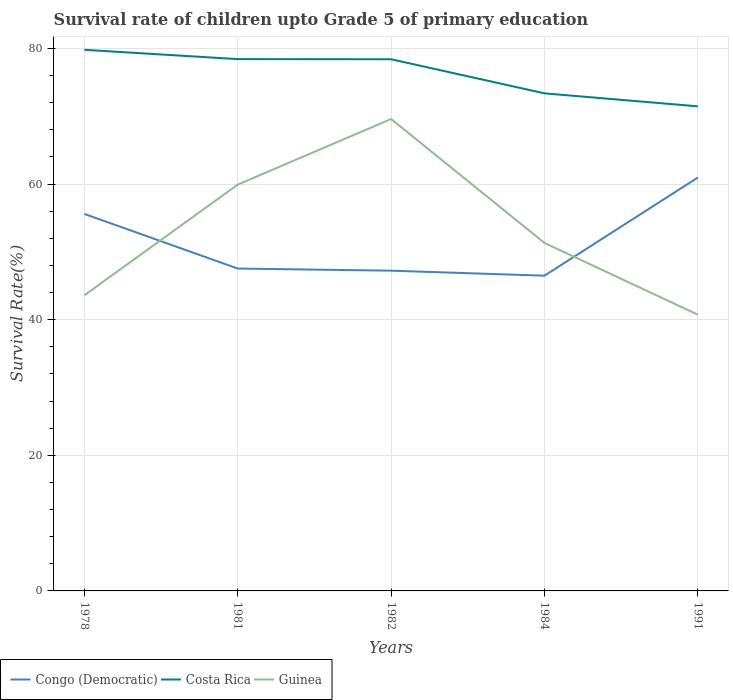Does the line corresponding to Guinea intersect with the line corresponding to Congo (Democratic)?
Offer a very short reply. Yes. Is the number of lines equal to the number of legend labels?
Keep it short and to the point. Yes. Across all years, what is the maximum survival rate of children in Guinea?
Ensure brevity in your answer.  40.74. What is the total survival rate of children in Guinea in the graph?
Provide a short and direct response. 8.6. What is the difference between the highest and the second highest survival rate of children in Costa Rica?
Ensure brevity in your answer.  8.34. Is the survival rate of children in Costa Rica strictly greater than the survival rate of children in Guinea over the years?
Make the answer very short. No. How many lines are there?
Provide a succinct answer. 3. How many years are there in the graph?
Your answer should be very brief. 5. What is the difference between two consecutive major ticks on the Y-axis?
Your answer should be compact. 20. Does the graph contain grids?
Provide a succinct answer. Yes. Where does the legend appear in the graph?
Provide a short and direct response. Bottom left. What is the title of the graph?
Your response must be concise. Survival rate of children upto Grade 5 of primary education. Does "Italy" appear as one of the legend labels in the graph?
Offer a terse response. No. What is the label or title of the X-axis?
Your answer should be compact. Years. What is the label or title of the Y-axis?
Offer a very short reply. Survival Rate(%). What is the Survival Rate(%) in Congo (Democratic) in 1978?
Provide a succinct answer. 55.59. What is the Survival Rate(%) in Costa Rica in 1978?
Your answer should be very brief. 79.79. What is the Survival Rate(%) in Guinea in 1978?
Offer a terse response. 43.6. What is the Survival Rate(%) of Congo (Democratic) in 1981?
Your answer should be compact. 47.54. What is the Survival Rate(%) of Costa Rica in 1981?
Make the answer very short. 78.42. What is the Survival Rate(%) in Guinea in 1981?
Make the answer very short. 59.92. What is the Survival Rate(%) in Congo (Democratic) in 1982?
Keep it short and to the point. 47.23. What is the Survival Rate(%) in Costa Rica in 1982?
Ensure brevity in your answer.  78.4. What is the Survival Rate(%) in Guinea in 1982?
Your response must be concise. 69.59. What is the Survival Rate(%) of Congo (Democratic) in 1984?
Offer a very short reply. 46.48. What is the Survival Rate(%) of Costa Rica in 1984?
Keep it short and to the point. 73.37. What is the Survival Rate(%) in Guinea in 1984?
Give a very brief answer. 51.31. What is the Survival Rate(%) in Congo (Democratic) in 1991?
Your response must be concise. 60.96. What is the Survival Rate(%) of Costa Rica in 1991?
Give a very brief answer. 71.46. What is the Survival Rate(%) in Guinea in 1991?
Your answer should be compact. 40.74. Across all years, what is the maximum Survival Rate(%) in Congo (Democratic)?
Ensure brevity in your answer.  60.96. Across all years, what is the maximum Survival Rate(%) in Costa Rica?
Your answer should be very brief. 79.79. Across all years, what is the maximum Survival Rate(%) in Guinea?
Your response must be concise. 69.59. Across all years, what is the minimum Survival Rate(%) of Congo (Democratic)?
Give a very brief answer. 46.48. Across all years, what is the minimum Survival Rate(%) of Costa Rica?
Offer a very short reply. 71.46. Across all years, what is the minimum Survival Rate(%) of Guinea?
Your answer should be very brief. 40.74. What is the total Survival Rate(%) of Congo (Democratic) in the graph?
Offer a terse response. 257.8. What is the total Survival Rate(%) in Costa Rica in the graph?
Give a very brief answer. 381.44. What is the total Survival Rate(%) in Guinea in the graph?
Offer a very short reply. 265.15. What is the difference between the Survival Rate(%) in Congo (Democratic) in 1978 and that in 1981?
Keep it short and to the point. 8.05. What is the difference between the Survival Rate(%) in Costa Rica in 1978 and that in 1981?
Your answer should be very brief. 1.37. What is the difference between the Survival Rate(%) of Guinea in 1978 and that in 1981?
Keep it short and to the point. -16.32. What is the difference between the Survival Rate(%) of Congo (Democratic) in 1978 and that in 1982?
Your answer should be compact. 8.36. What is the difference between the Survival Rate(%) in Costa Rica in 1978 and that in 1982?
Your answer should be compact. 1.39. What is the difference between the Survival Rate(%) of Guinea in 1978 and that in 1982?
Provide a succinct answer. -25.99. What is the difference between the Survival Rate(%) in Congo (Democratic) in 1978 and that in 1984?
Ensure brevity in your answer.  9.11. What is the difference between the Survival Rate(%) of Costa Rica in 1978 and that in 1984?
Ensure brevity in your answer.  6.42. What is the difference between the Survival Rate(%) of Guinea in 1978 and that in 1984?
Offer a very short reply. -7.72. What is the difference between the Survival Rate(%) in Congo (Democratic) in 1978 and that in 1991?
Your answer should be compact. -5.37. What is the difference between the Survival Rate(%) in Costa Rica in 1978 and that in 1991?
Ensure brevity in your answer.  8.34. What is the difference between the Survival Rate(%) of Guinea in 1978 and that in 1991?
Give a very brief answer. 2.86. What is the difference between the Survival Rate(%) of Congo (Democratic) in 1981 and that in 1982?
Your answer should be compact. 0.31. What is the difference between the Survival Rate(%) of Costa Rica in 1981 and that in 1982?
Ensure brevity in your answer.  0.02. What is the difference between the Survival Rate(%) of Guinea in 1981 and that in 1982?
Ensure brevity in your answer.  -9.67. What is the difference between the Survival Rate(%) of Congo (Democratic) in 1981 and that in 1984?
Provide a succinct answer. 1.05. What is the difference between the Survival Rate(%) of Costa Rica in 1981 and that in 1984?
Your response must be concise. 5.05. What is the difference between the Survival Rate(%) of Guinea in 1981 and that in 1984?
Provide a succinct answer. 8.6. What is the difference between the Survival Rate(%) in Congo (Democratic) in 1981 and that in 1991?
Your answer should be compact. -13.42. What is the difference between the Survival Rate(%) of Costa Rica in 1981 and that in 1991?
Your answer should be very brief. 6.97. What is the difference between the Survival Rate(%) in Guinea in 1981 and that in 1991?
Offer a very short reply. 19.18. What is the difference between the Survival Rate(%) of Congo (Democratic) in 1982 and that in 1984?
Your answer should be compact. 0.74. What is the difference between the Survival Rate(%) of Costa Rica in 1982 and that in 1984?
Keep it short and to the point. 5.03. What is the difference between the Survival Rate(%) of Guinea in 1982 and that in 1984?
Your answer should be compact. 18.27. What is the difference between the Survival Rate(%) in Congo (Democratic) in 1982 and that in 1991?
Offer a very short reply. -13.73. What is the difference between the Survival Rate(%) of Costa Rica in 1982 and that in 1991?
Keep it short and to the point. 6.94. What is the difference between the Survival Rate(%) in Guinea in 1982 and that in 1991?
Provide a short and direct response. 28.84. What is the difference between the Survival Rate(%) of Congo (Democratic) in 1984 and that in 1991?
Provide a short and direct response. -14.47. What is the difference between the Survival Rate(%) of Costa Rica in 1984 and that in 1991?
Offer a very short reply. 1.92. What is the difference between the Survival Rate(%) of Guinea in 1984 and that in 1991?
Your answer should be compact. 10.57. What is the difference between the Survival Rate(%) in Congo (Democratic) in 1978 and the Survival Rate(%) in Costa Rica in 1981?
Provide a succinct answer. -22.83. What is the difference between the Survival Rate(%) in Congo (Democratic) in 1978 and the Survival Rate(%) in Guinea in 1981?
Provide a short and direct response. -4.33. What is the difference between the Survival Rate(%) of Costa Rica in 1978 and the Survival Rate(%) of Guinea in 1981?
Keep it short and to the point. 19.88. What is the difference between the Survival Rate(%) of Congo (Democratic) in 1978 and the Survival Rate(%) of Costa Rica in 1982?
Offer a terse response. -22.81. What is the difference between the Survival Rate(%) in Congo (Democratic) in 1978 and the Survival Rate(%) in Guinea in 1982?
Offer a terse response. -14. What is the difference between the Survival Rate(%) in Costa Rica in 1978 and the Survival Rate(%) in Guinea in 1982?
Your response must be concise. 10.21. What is the difference between the Survival Rate(%) in Congo (Democratic) in 1978 and the Survival Rate(%) in Costa Rica in 1984?
Keep it short and to the point. -17.78. What is the difference between the Survival Rate(%) in Congo (Democratic) in 1978 and the Survival Rate(%) in Guinea in 1984?
Your response must be concise. 4.28. What is the difference between the Survival Rate(%) in Costa Rica in 1978 and the Survival Rate(%) in Guinea in 1984?
Offer a terse response. 28.48. What is the difference between the Survival Rate(%) of Congo (Democratic) in 1978 and the Survival Rate(%) of Costa Rica in 1991?
Provide a succinct answer. -15.87. What is the difference between the Survival Rate(%) in Congo (Democratic) in 1978 and the Survival Rate(%) in Guinea in 1991?
Offer a terse response. 14.85. What is the difference between the Survival Rate(%) of Costa Rica in 1978 and the Survival Rate(%) of Guinea in 1991?
Your answer should be compact. 39.05. What is the difference between the Survival Rate(%) in Congo (Democratic) in 1981 and the Survival Rate(%) in Costa Rica in 1982?
Your response must be concise. -30.86. What is the difference between the Survival Rate(%) in Congo (Democratic) in 1981 and the Survival Rate(%) in Guinea in 1982?
Make the answer very short. -22.05. What is the difference between the Survival Rate(%) of Costa Rica in 1981 and the Survival Rate(%) of Guinea in 1982?
Your answer should be very brief. 8.84. What is the difference between the Survival Rate(%) of Congo (Democratic) in 1981 and the Survival Rate(%) of Costa Rica in 1984?
Ensure brevity in your answer.  -25.84. What is the difference between the Survival Rate(%) of Congo (Democratic) in 1981 and the Survival Rate(%) of Guinea in 1984?
Offer a very short reply. -3.78. What is the difference between the Survival Rate(%) in Costa Rica in 1981 and the Survival Rate(%) in Guinea in 1984?
Provide a short and direct response. 27.11. What is the difference between the Survival Rate(%) in Congo (Democratic) in 1981 and the Survival Rate(%) in Costa Rica in 1991?
Make the answer very short. -23.92. What is the difference between the Survival Rate(%) of Congo (Democratic) in 1981 and the Survival Rate(%) of Guinea in 1991?
Your response must be concise. 6.8. What is the difference between the Survival Rate(%) of Costa Rica in 1981 and the Survival Rate(%) of Guinea in 1991?
Your response must be concise. 37.68. What is the difference between the Survival Rate(%) in Congo (Democratic) in 1982 and the Survival Rate(%) in Costa Rica in 1984?
Ensure brevity in your answer.  -26.15. What is the difference between the Survival Rate(%) in Congo (Democratic) in 1982 and the Survival Rate(%) in Guinea in 1984?
Your response must be concise. -4.09. What is the difference between the Survival Rate(%) of Costa Rica in 1982 and the Survival Rate(%) of Guinea in 1984?
Make the answer very short. 27.09. What is the difference between the Survival Rate(%) of Congo (Democratic) in 1982 and the Survival Rate(%) of Costa Rica in 1991?
Your answer should be compact. -24.23. What is the difference between the Survival Rate(%) in Congo (Democratic) in 1982 and the Survival Rate(%) in Guinea in 1991?
Your answer should be compact. 6.48. What is the difference between the Survival Rate(%) of Costa Rica in 1982 and the Survival Rate(%) of Guinea in 1991?
Your answer should be very brief. 37.66. What is the difference between the Survival Rate(%) of Congo (Democratic) in 1984 and the Survival Rate(%) of Costa Rica in 1991?
Offer a terse response. -24.97. What is the difference between the Survival Rate(%) of Congo (Democratic) in 1984 and the Survival Rate(%) of Guinea in 1991?
Your answer should be very brief. 5.74. What is the difference between the Survival Rate(%) in Costa Rica in 1984 and the Survival Rate(%) in Guinea in 1991?
Provide a short and direct response. 32.63. What is the average Survival Rate(%) in Congo (Democratic) per year?
Make the answer very short. 51.56. What is the average Survival Rate(%) in Costa Rica per year?
Your answer should be very brief. 76.29. What is the average Survival Rate(%) of Guinea per year?
Your answer should be compact. 53.03. In the year 1978, what is the difference between the Survival Rate(%) of Congo (Democratic) and Survival Rate(%) of Costa Rica?
Offer a terse response. -24.2. In the year 1978, what is the difference between the Survival Rate(%) of Congo (Democratic) and Survival Rate(%) of Guinea?
Provide a short and direct response. 11.99. In the year 1978, what is the difference between the Survival Rate(%) in Costa Rica and Survival Rate(%) in Guinea?
Keep it short and to the point. 36.19. In the year 1981, what is the difference between the Survival Rate(%) in Congo (Democratic) and Survival Rate(%) in Costa Rica?
Provide a short and direct response. -30.88. In the year 1981, what is the difference between the Survival Rate(%) in Congo (Democratic) and Survival Rate(%) in Guinea?
Make the answer very short. -12.38. In the year 1981, what is the difference between the Survival Rate(%) of Costa Rica and Survival Rate(%) of Guinea?
Offer a very short reply. 18.51. In the year 1982, what is the difference between the Survival Rate(%) of Congo (Democratic) and Survival Rate(%) of Costa Rica?
Give a very brief answer. -31.18. In the year 1982, what is the difference between the Survival Rate(%) of Congo (Democratic) and Survival Rate(%) of Guinea?
Make the answer very short. -22.36. In the year 1982, what is the difference between the Survival Rate(%) of Costa Rica and Survival Rate(%) of Guinea?
Your answer should be very brief. 8.82. In the year 1984, what is the difference between the Survival Rate(%) of Congo (Democratic) and Survival Rate(%) of Costa Rica?
Offer a very short reply. -26.89. In the year 1984, what is the difference between the Survival Rate(%) in Congo (Democratic) and Survival Rate(%) in Guinea?
Ensure brevity in your answer.  -4.83. In the year 1984, what is the difference between the Survival Rate(%) in Costa Rica and Survival Rate(%) in Guinea?
Make the answer very short. 22.06. In the year 1991, what is the difference between the Survival Rate(%) of Congo (Democratic) and Survival Rate(%) of Costa Rica?
Offer a terse response. -10.5. In the year 1991, what is the difference between the Survival Rate(%) of Congo (Democratic) and Survival Rate(%) of Guinea?
Give a very brief answer. 20.22. In the year 1991, what is the difference between the Survival Rate(%) in Costa Rica and Survival Rate(%) in Guinea?
Offer a very short reply. 30.72. What is the ratio of the Survival Rate(%) of Congo (Democratic) in 1978 to that in 1981?
Keep it short and to the point. 1.17. What is the ratio of the Survival Rate(%) of Costa Rica in 1978 to that in 1981?
Your answer should be very brief. 1.02. What is the ratio of the Survival Rate(%) in Guinea in 1978 to that in 1981?
Ensure brevity in your answer.  0.73. What is the ratio of the Survival Rate(%) in Congo (Democratic) in 1978 to that in 1982?
Provide a short and direct response. 1.18. What is the ratio of the Survival Rate(%) of Costa Rica in 1978 to that in 1982?
Offer a very short reply. 1.02. What is the ratio of the Survival Rate(%) of Guinea in 1978 to that in 1982?
Provide a succinct answer. 0.63. What is the ratio of the Survival Rate(%) of Congo (Democratic) in 1978 to that in 1984?
Your answer should be very brief. 1.2. What is the ratio of the Survival Rate(%) in Costa Rica in 1978 to that in 1984?
Your response must be concise. 1.09. What is the ratio of the Survival Rate(%) in Guinea in 1978 to that in 1984?
Your answer should be very brief. 0.85. What is the ratio of the Survival Rate(%) in Congo (Democratic) in 1978 to that in 1991?
Your response must be concise. 0.91. What is the ratio of the Survival Rate(%) in Costa Rica in 1978 to that in 1991?
Your answer should be very brief. 1.12. What is the ratio of the Survival Rate(%) in Guinea in 1978 to that in 1991?
Make the answer very short. 1.07. What is the ratio of the Survival Rate(%) in Congo (Democratic) in 1981 to that in 1982?
Provide a short and direct response. 1.01. What is the ratio of the Survival Rate(%) in Costa Rica in 1981 to that in 1982?
Offer a very short reply. 1. What is the ratio of the Survival Rate(%) in Guinea in 1981 to that in 1982?
Your response must be concise. 0.86. What is the ratio of the Survival Rate(%) in Congo (Democratic) in 1981 to that in 1984?
Your answer should be compact. 1.02. What is the ratio of the Survival Rate(%) of Costa Rica in 1981 to that in 1984?
Your response must be concise. 1.07. What is the ratio of the Survival Rate(%) in Guinea in 1981 to that in 1984?
Your answer should be compact. 1.17. What is the ratio of the Survival Rate(%) in Congo (Democratic) in 1981 to that in 1991?
Provide a succinct answer. 0.78. What is the ratio of the Survival Rate(%) of Costa Rica in 1981 to that in 1991?
Provide a short and direct response. 1.1. What is the ratio of the Survival Rate(%) in Guinea in 1981 to that in 1991?
Your response must be concise. 1.47. What is the ratio of the Survival Rate(%) in Congo (Democratic) in 1982 to that in 1984?
Offer a terse response. 1.02. What is the ratio of the Survival Rate(%) in Costa Rica in 1982 to that in 1984?
Your answer should be very brief. 1.07. What is the ratio of the Survival Rate(%) of Guinea in 1982 to that in 1984?
Provide a succinct answer. 1.36. What is the ratio of the Survival Rate(%) in Congo (Democratic) in 1982 to that in 1991?
Your response must be concise. 0.77. What is the ratio of the Survival Rate(%) in Costa Rica in 1982 to that in 1991?
Provide a succinct answer. 1.1. What is the ratio of the Survival Rate(%) in Guinea in 1982 to that in 1991?
Give a very brief answer. 1.71. What is the ratio of the Survival Rate(%) in Congo (Democratic) in 1984 to that in 1991?
Ensure brevity in your answer.  0.76. What is the ratio of the Survival Rate(%) of Costa Rica in 1984 to that in 1991?
Offer a very short reply. 1.03. What is the ratio of the Survival Rate(%) of Guinea in 1984 to that in 1991?
Offer a terse response. 1.26. What is the difference between the highest and the second highest Survival Rate(%) in Congo (Democratic)?
Offer a very short reply. 5.37. What is the difference between the highest and the second highest Survival Rate(%) of Costa Rica?
Keep it short and to the point. 1.37. What is the difference between the highest and the second highest Survival Rate(%) in Guinea?
Provide a short and direct response. 9.67. What is the difference between the highest and the lowest Survival Rate(%) of Congo (Democratic)?
Offer a very short reply. 14.47. What is the difference between the highest and the lowest Survival Rate(%) of Costa Rica?
Offer a very short reply. 8.34. What is the difference between the highest and the lowest Survival Rate(%) in Guinea?
Your response must be concise. 28.84. 